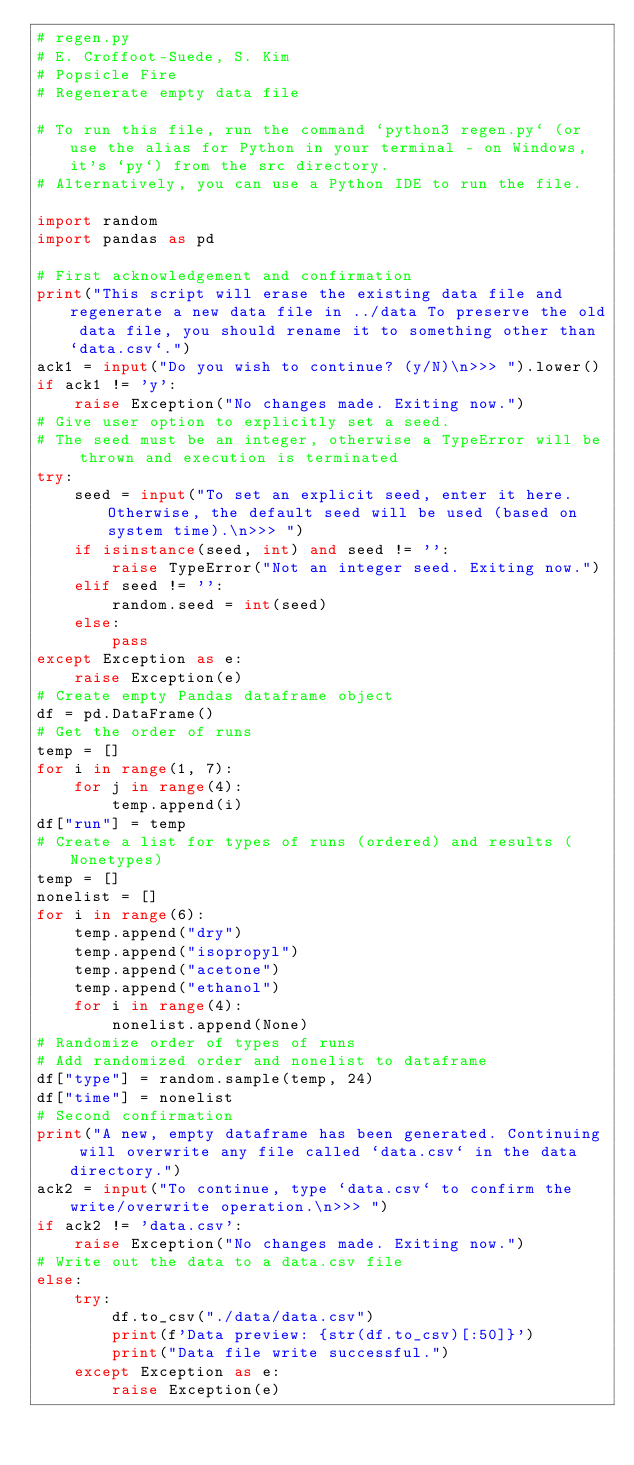<code> <loc_0><loc_0><loc_500><loc_500><_Python_># regen.py
# E. Croffoot-Suede, S. Kim
# Popsicle Fire
# Regenerate empty data file

# To run this file, run the command `python3 regen.py` (or use the alias for Python in your terminal - on Windows, it's `py`) from the src directory.
# Alternatively, you can use a Python IDE to run the file.

import random
import pandas as pd

# First acknowledgement and confirmation
print("This script will erase the existing data file and regenerate a new data file in ../data To preserve the old data file, you should rename it to something other than `data.csv`.")
ack1 = input("Do you wish to continue? (y/N)\n>>> ").lower()
if ack1 != 'y':
    raise Exception("No changes made. Exiting now.")
# Give user option to explicitly set a seed.
# The seed must be an integer, otherwise a TypeError will be thrown and execution is terminated
try:
    seed = input("To set an explicit seed, enter it here. Otherwise, the default seed will be used (based on system time).\n>>> ")
    if isinstance(seed, int) and seed != '':
        raise TypeError("Not an integer seed. Exiting now.")
    elif seed != '':
        random.seed = int(seed)
    else:
        pass
except Exception as e:
    raise Exception(e)
# Create empty Pandas dataframe object
df = pd.DataFrame()
# Get the order of runs
temp = []
for i in range(1, 7):
    for j in range(4):
        temp.append(i)
df["run"] = temp
# Create a list for types of runs (ordered) and results (Nonetypes)
temp = []
nonelist = []
for i in range(6):
    temp.append("dry")
    temp.append("isopropyl")
    temp.append("acetone")
    temp.append("ethanol")
    for i in range(4):
        nonelist.append(None)
# Randomize order of types of runs
# Add randomized order and nonelist to dataframe
df["type"] = random.sample(temp, 24)
df["time"] = nonelist
# Second confirmation
print("A new, empty dataframe has been generated. Continuing will overwrite any file called `data.csv` in the data directory.")
ack2 = input("To continue, type `data.csv` to confirm the write/overwrite operation.\n>>> ")
if ack2 != 'data.csv':
    raise Exception("No changes made. Exiting now.")
# Write out the data to a data.csv file
else:
    try:
        df.to_csv("./data/data.csv")
        print(f'Data preview: {str(df.to_csv)[:50]}')
        print("Data file write successful.")
    except Exception as e:
        raise Exception(e)</code> 